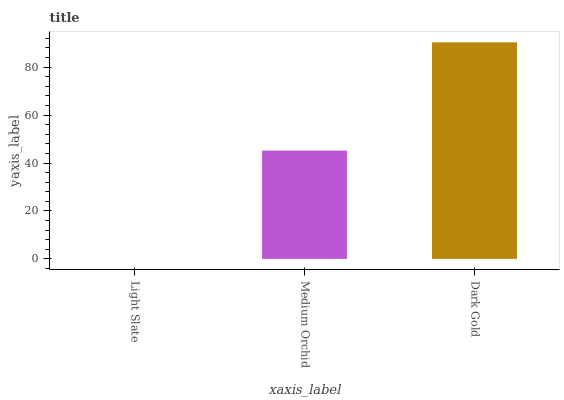Is Light Slate the minimum?
Answer yes or no. Yes. Is Dark Gold the maximum?
Answer yes or no. Yes. Is Medium Orchid the minimum?
Answer yes or no. No. Is Medium Orchid the maximum?
Answer yes or no. No. Is Medium Orchid greater than Light Slate?
Answer yes or no. Yes. Is Light Slate less than Medium Orchid?
Answer yes or no. Yes. Is Light Slate greater than Medium Orchid?
Answer yes or no. No. Is Medium Orchid less than Light Slate?
Answer yes or no. No. Is Medium Orchid the high median?
Answer yes or no. Yes. Is Medium Orchid the low median?
Answer yes or no. Yes. Is Light Slate the high median?
Answer yes or no. No. Is Light Slate the low median?
Answer yes or no. No. 